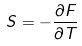<formula> <loc_0><loc_0><loc_500><loc_500>S = - \frac { \partial F } { \partial T }</formula> 